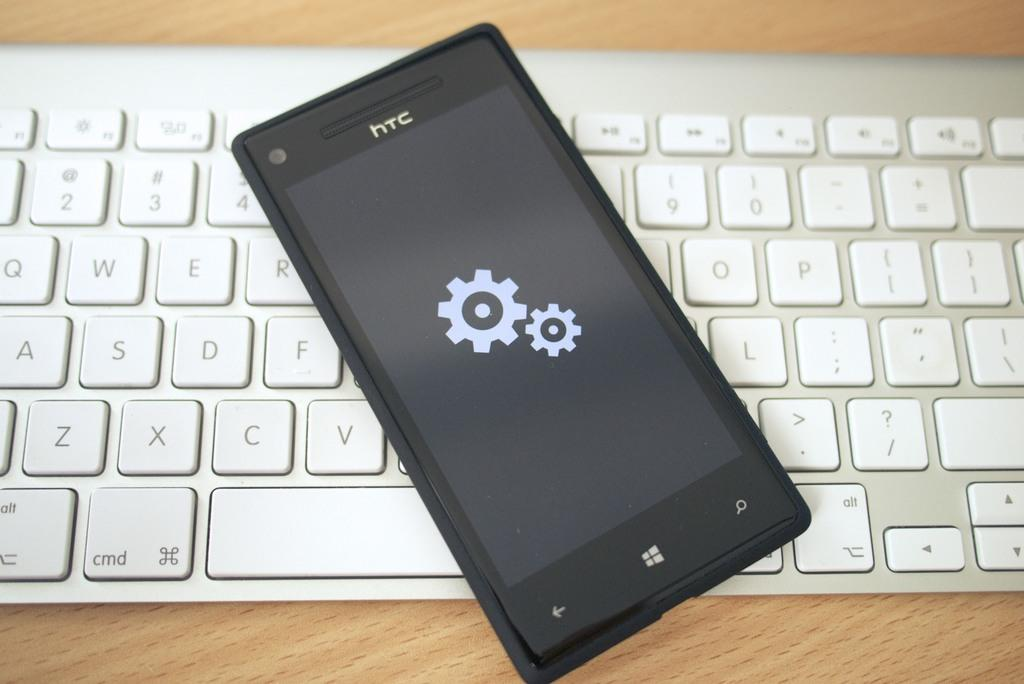<image>
Write a terse but informative summary of the picture. A phone which has htc written above the screen 